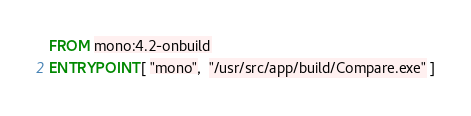<code> <loc_0><loc_0><loc_500><loc_500><_Dockerfile_>FROM mono:4.2-onbuild
ENTRYPOINT [ "mono",  "/usr/src/app/build/Compare.exe" ]
</code> 